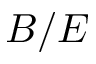<formula> <loc_0><loc_0><loc_500><loc_500>B / E</formula> 